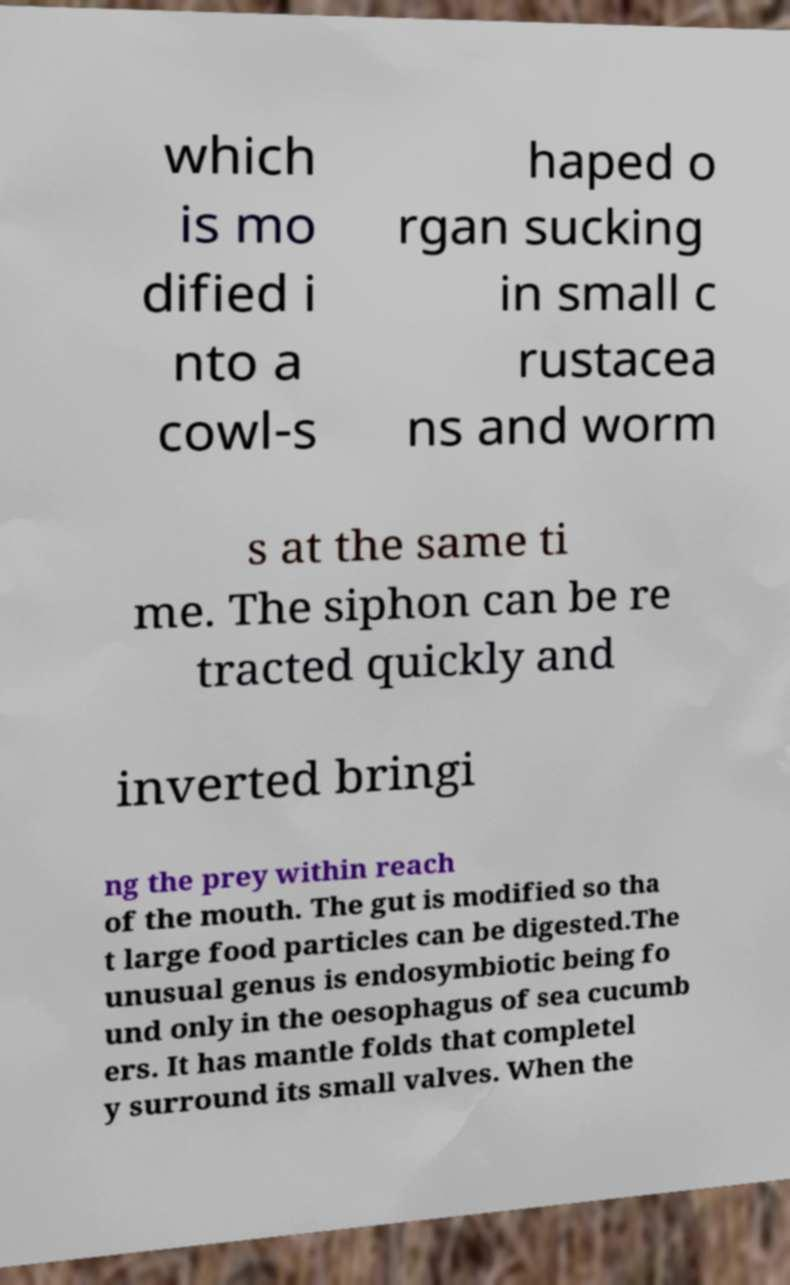Can you accurately transcribe the text from the provided image for me? which is mo dified i nto a cowl-s haped o rgan sucking in small c rustacea ns and worm s at the same ti me. The siphon can be re tracted quickly and inverted bringi ng the prey within reach of the mouth. The gut is modified so tha t large food particles can be digested.The unusual genus is endosymbiotic being fo und only in the oesophagus of sea cucumb ers. It has mantle folds that completel y surround its small valves. When the 